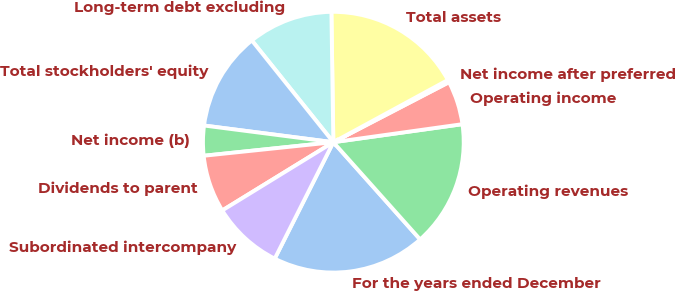Convert chart to OTSL. <chart><loc_0><loc_0><loc_500><loc_500><pie_chart><fcel>For the years ended December<fcel>Operating revenues<fcel>Operating income<fcel>Net income after preferred<fcel>Total assets<fcel>Long-term debt excluding<fcel>Total stockholders' equity<fcel>Net income (b)<fcel>Dividends to parent<fcel>Subordinated intercompany<nl><fcel>19.02%<fcel>15.61%<fcel>5.41%<fcel>0.3%<fcel>17.32%<fcel>10.51%<fcel>12.21%<fcel>3.7%<fcel>7.11%<fcel>8.81%<nl></chart> 